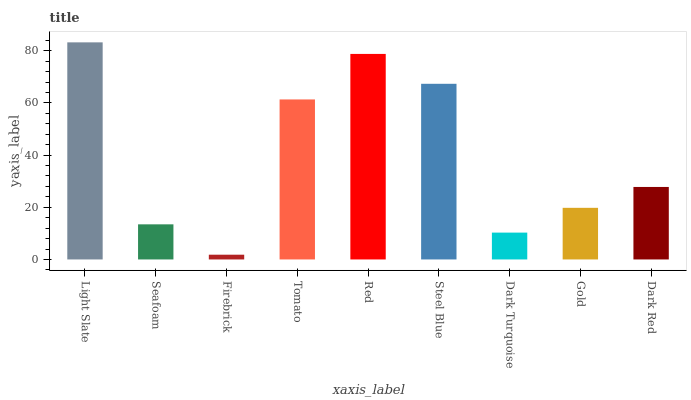Is Firebrick the minimum?
Answer yes or no. Yes. Is Light Slate the maximum?
Answer yes or no. Yes. Is Seafoam the minimum?
Answer yes or no. No. Is Seafoam the maximum?
Answer yes or no. No. Is Light Slate greater than Seafoam?
Answer yes or no. Yes. Is Seafoam less than Light Slate?
Answer yes or no. Yes. Is Seafoam greater than Light Slate?
Answer yes or no. No. Is Light Slate less than Seafoam?
Answer yes or no. No. Is Dark Red the high median?
Answer yes or no. Yes. Is Dark Red the low median?
Answer yes or no. Yes. Is Red the high median?
Answer yes or no. No. Is Light Slate the low median?
Answer yes or no. No. 